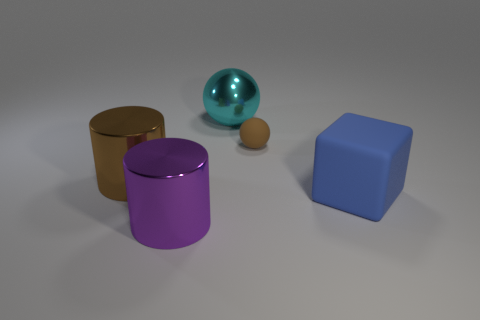How many blue objects have the same shape as the large cyan metallic object?
Give a very brief answer. 0. Do the large brown cylinder and the big cylinder in front of the big block have the same material?
Provide a short and direct response. Yes. What is the size of the ball that is the same material as the brown cylinder?
Offer a very short reply. Large. There is a object that is right of the brown rubber ball; what size is it?
Offer a very short reply. Large. How many cyan objects are the same size as the brown ball?
Offer a terse response. 0. There is a cylinder that is the same color as the matte ball; what is its size?
Your response must be concise. Large. Are there any shiny cylinders that have the same color as the big block?
Give a very brief answer. No. What is the color of the block that is the same size as the cyan thing?
Offer a very short reply. Blue. There is a tiny ball; does it have the same color as the rubber object in front of the rubber sphere?
Ensure brevity in your answer.  No. The tiny matte object is what color?
Offer a very short reply. Brown. 